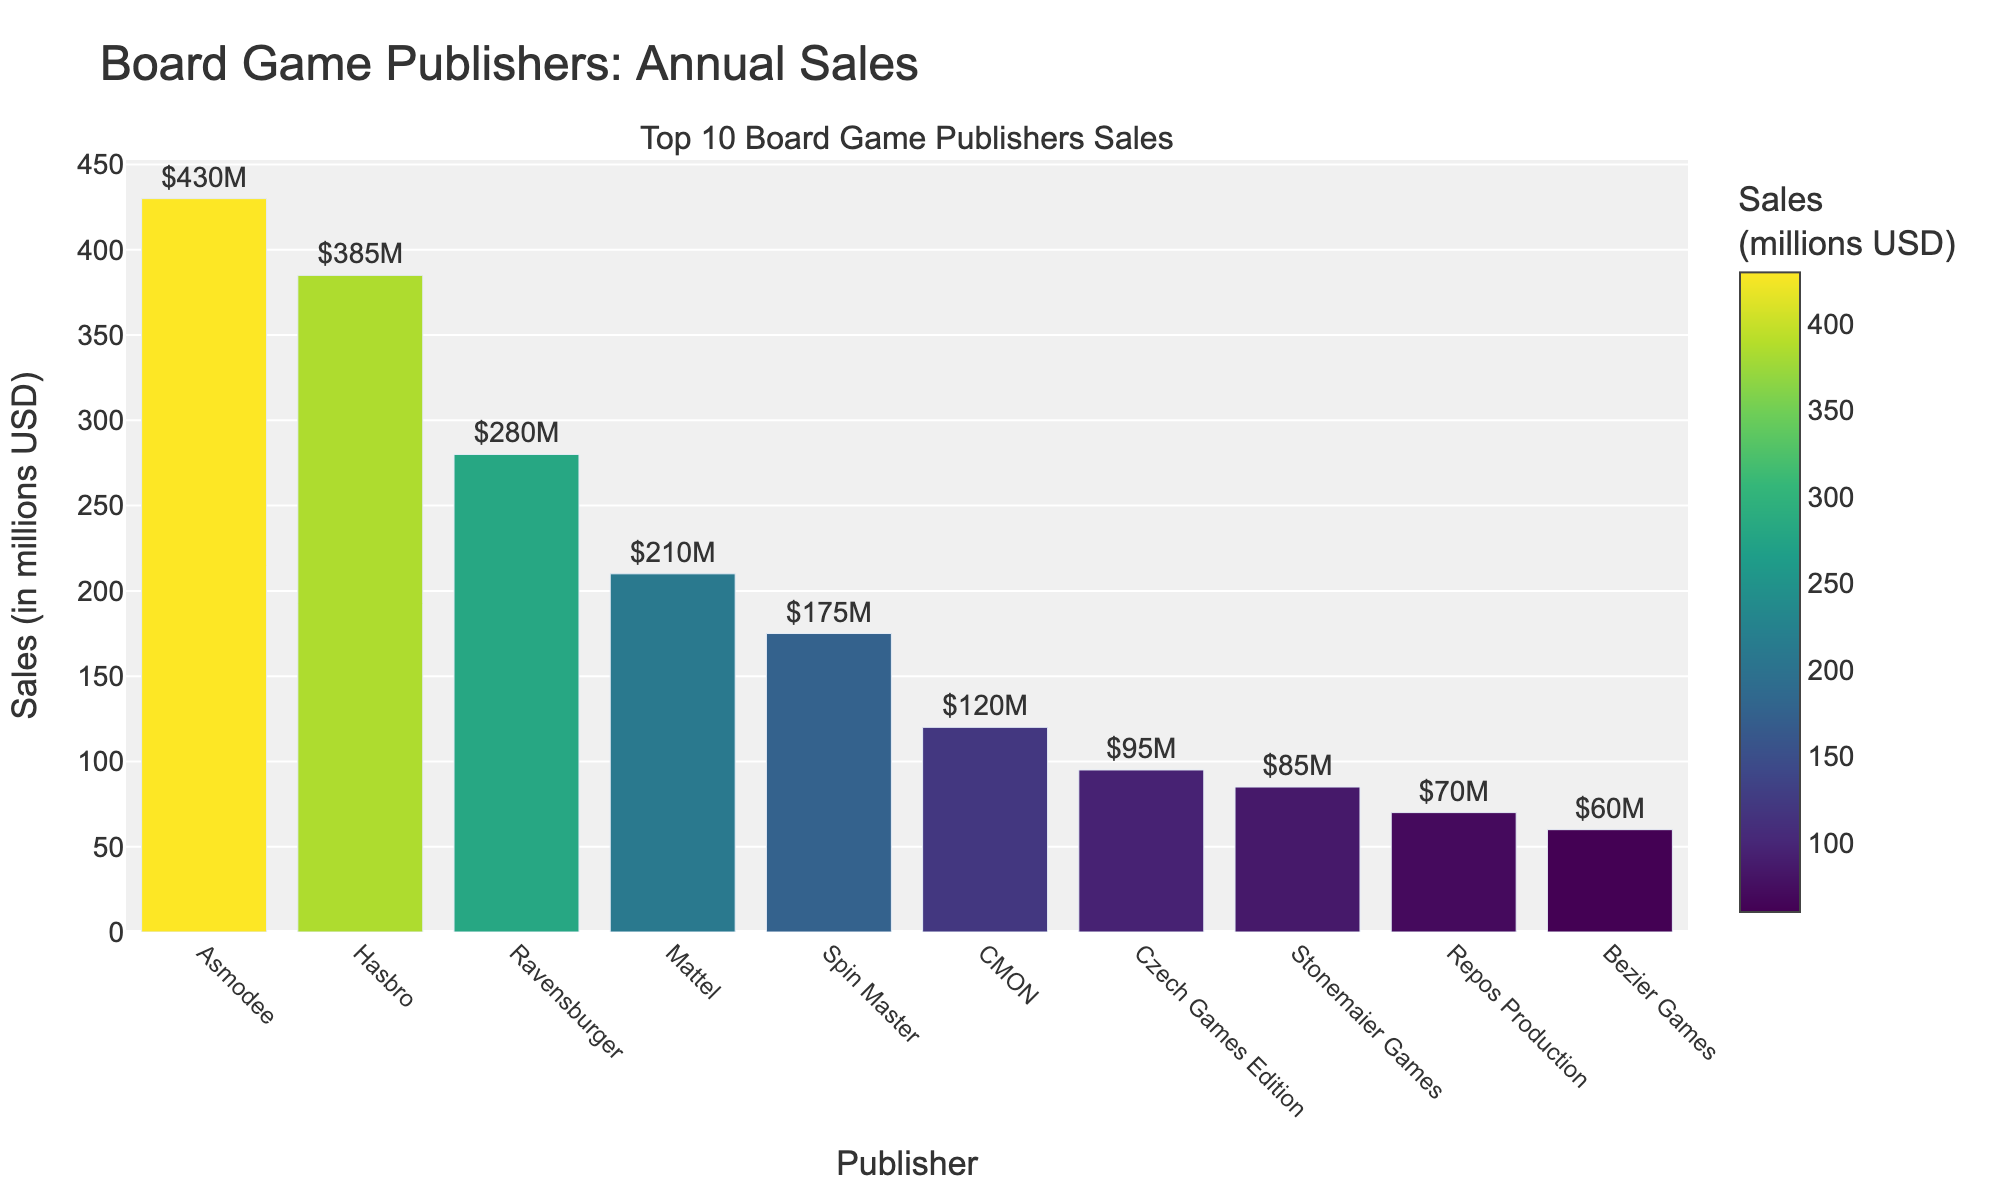What publisher has the highest annual sales? The highest bar visually represents the annual sales of Asmodee at $430 million. Asmodee's bar is taller than the rest, indicating that it leads in sales among the listed publishers.
Answer: Asmodee Which publisher has the lowest sales among the top 10? By observing the bars, Bezier Games has the shortest bar, meaning it has the lowest sales value of $60 million among the top 10 publishers.
Answer: Bezier Games What is the total sales figure for Hasbro and Mattel combined? The sales figures for Hasbro and Mattel are $385 million and $210 million, respectively. Summing these values gives $385M + $210M = $595M.
Answer: $595M How much more did Asmodee sell than Spin Master? Asmodee's sales are $430 million, while Spin Master's sales are $175 million. The difference is $430M - $175M = $255M.
Answer: $255M Which publisher had sales that were closest to $100 million? Czech Games Edition's sales are $95 million, which is the closest figure to $100 million among the listed publishers.
Answer: Czech Games Edition Among the publishers listed, how many have sales figures greater than $200 million? By reviewing the chart, the publishers with sales greater than $200 million are Asmodee ($430M), Hasbro ($385M), Ravensburger ($280M), and Mattel ($210M). This counts as 4 publishers.
Answer: 4 What is the average sales figure for the top 3 publishers? The sales figures for the top 3 are Asmodee ($430M), Hasbro ($385M), and Ravensburger ($280M). Adding these gives $430M + $385M + $280M = $1,095M. Dividing by 3 gives $1,095M / 3 = $365M.
Answer: $365M Of the publishers listed, which one is right in the middle in terms of sales figures? When the publishers are ordered by sales, Spin Master ($175M) is the 5th publisher and CMON ($120M) is the 6th. There are 10 publishers in total, so these two fall in the middle.
Answer: Spin Master and CMON What is the combined sales figure for the smallest three publishers? The three publishers with the lowest sales are Bezier Games ($60M), Repos Production ($70M), and Stonemaier Games ($85M). Summing these gives $60M + $70M + $85M = $215M.
Answer: $215M Compare the sales of Ravensburger and CMON, and state which one has a greater sales figure. Ravensburger's sales are $280 million while CMON's sales are $120 million. Since $280 million is greater than $120 million, Ravensburger has a greater sales figure.
Answer: Ravensburger 